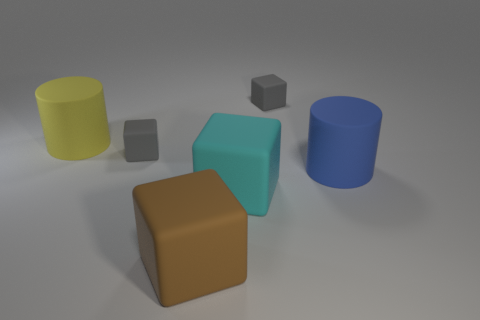There is another big object that is the same shape as the yellow rubber thing; what is its material?
Your answer should be very brief. Rubber. Are there any small matte objects?
Provide a short and direct response. Yes. There is a brown block that is the same material as the big cyan thing; what is its size?
Make the answer very short. Large. There is a small gray rubber thing that is in front of the cylinder that is to the left of the large block that is in front of the big cyan thing; what is its shape?
Keep it short and to the point. Cube. Is the number of big yellow things that are in front of the yellow cylinder the same as the number of purple metal objects?
Provide a succinct answer. Yes. Is the brown object the same shape as the blue thing?
Your answer should be compact. No. How many objects are either gray matte objects that are right of the cyan block or big red cubes?
Your answer should be very brief. 1. Is the number of matte things that are in front of the yellow rubber cylinder the same as the number of things that are behind the big cyan thing?
Make the answer very short. Yes. What number of other objects are there of the same shape as the large brown rubber thing?
Your response must be concise. 3. Does the gray rubber thing behind the big yellow matte thing have the same size as the rubber cylinder that is left of the big cyan thing?
Your answer should be very brief. No. 